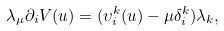Convert formula to latex. <formula><loc_0><loc_0><loc_500><loc_500>\lambda _ { \mu } \partial _ { i } V ( u ) = ( \upsilon _ { i } ^ { k } ( u ) - \mu \delta _ { i } ^ { k } ) \lambda _ { k } ,</formula> 